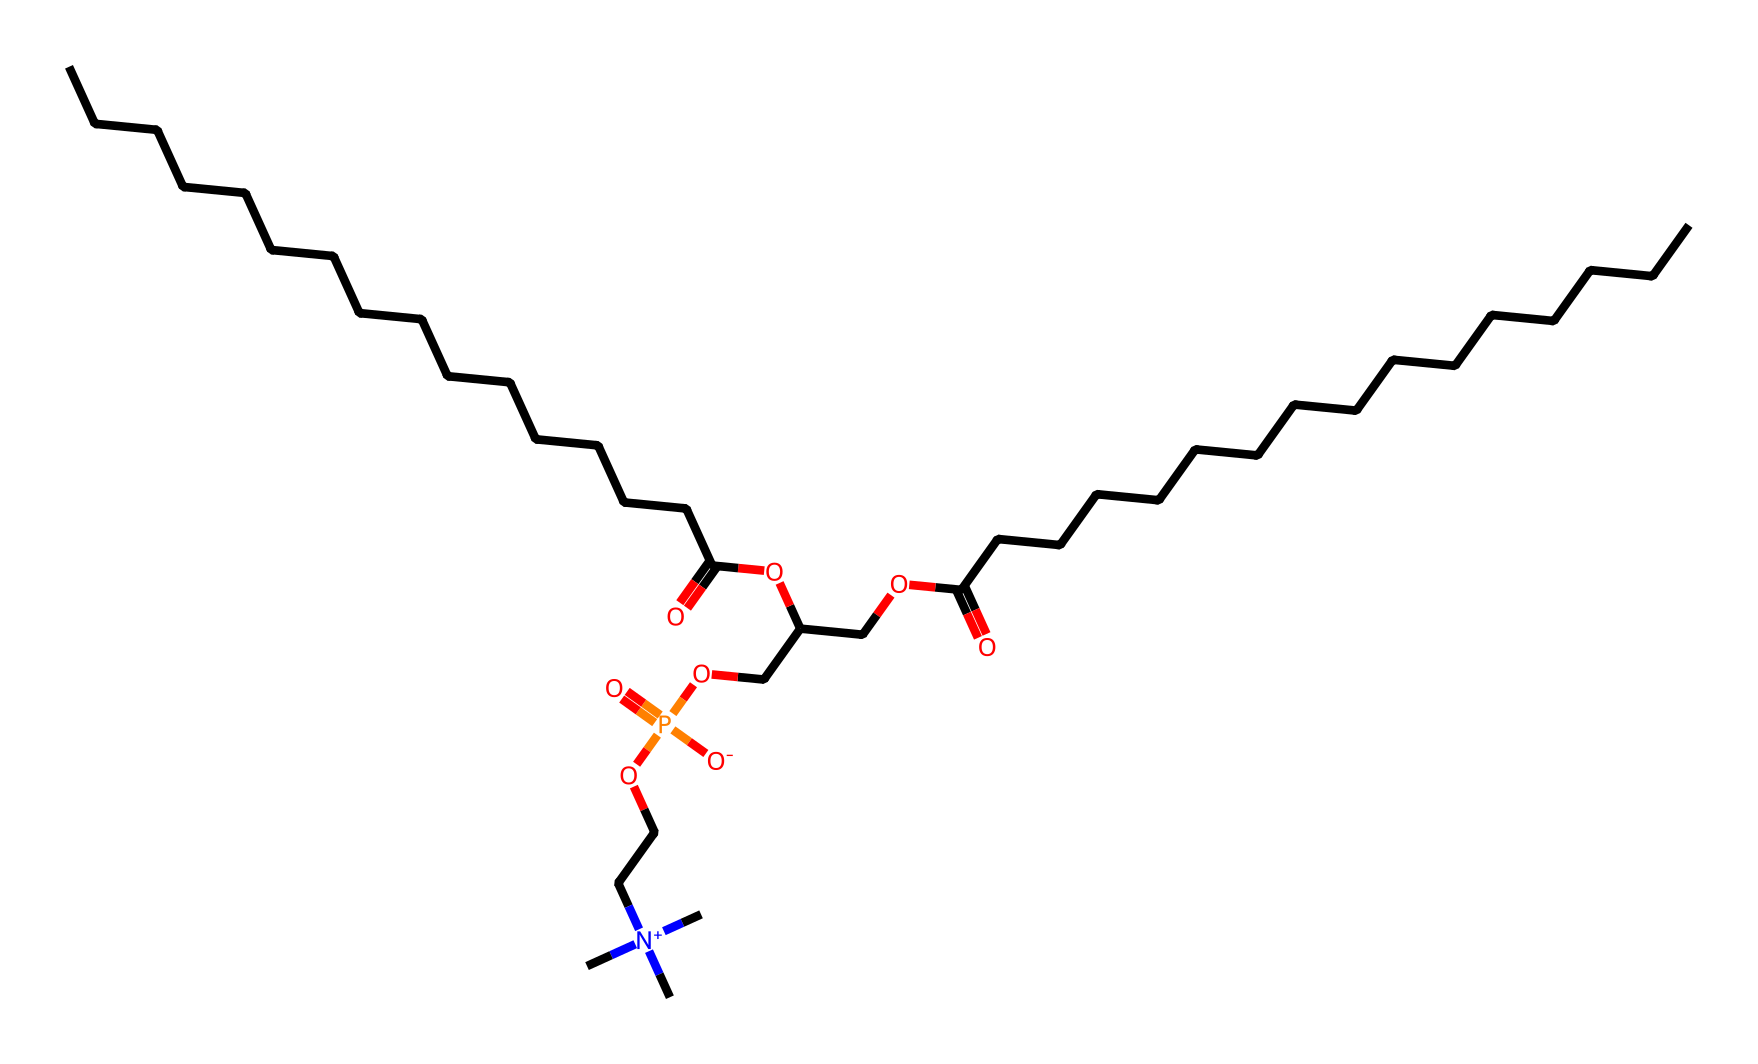What is the total number of carbon atoms in this phospholipid? By analyzing the SMILES representation, we count the carbon atoms represented by "C". Each "C" in the chain indicates a carbon atom. In the provided structure, we can see there are a total of 36 carbon atoms.
Answer: 36 How many phosphate groups are present in this chemical? The phosphate group is indicated by "P", which shows where phosphorus is included in the structure. Observing the SMILES, there is only one "P" indicating a single phosphate group.
Answer: 1 What functional group is indicated by "OCC(COP(=O)([O-])OCC[N+](C)(C)C)"? This portion of the structure contains "COP(=O)", indicating a phosphate group followed by an alcohol group. By interpreting the functional groups, we identify that it's a phosphoester functional group linked to a sugar alcohol.
Answer: phosphoester Does this phospholipid have a hydrophilic part? Yes, a phospholipid contains a hydrophilic (water-attracting) part. The part with the phosphate group, "COP(=O)([O-])", contributes to its water-loving characteristics, making it hydrophilic.
Answer: Yes Is this structure likely to form bilayers in an aqueous environment? Yes, phospholipids spontaneously orient themselves to form bilayers in water due to their amphipathic nature (having both hydrophilic and hydrophobic parts). The hydrophilic head interacts with water, while the hydrophobic tails avoid it, leading to bilayer formation.
Answer: Yes 